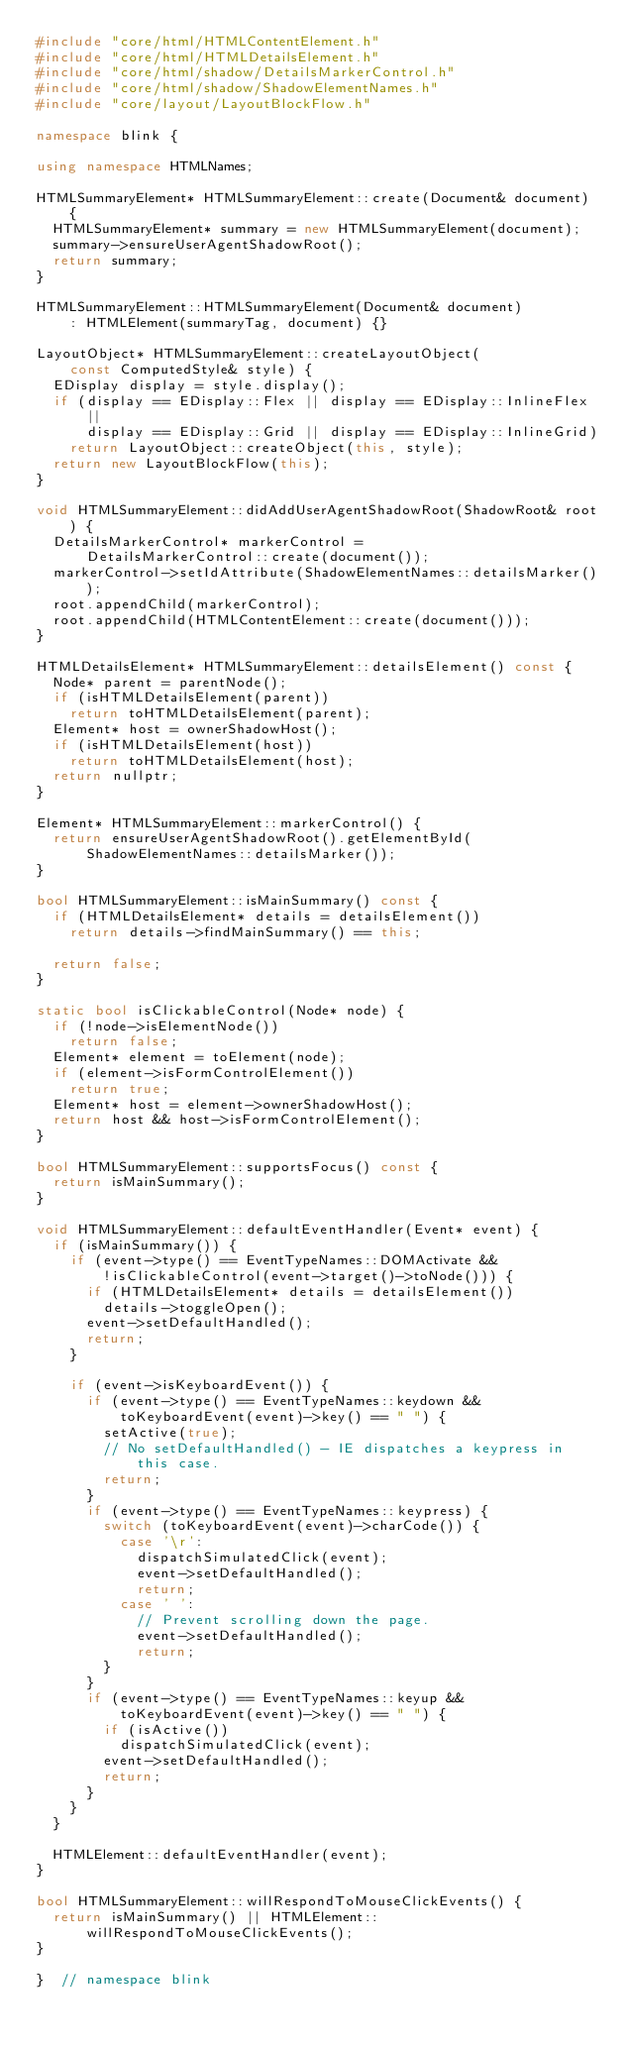<code> <loc_0><loc_0><loc_500><loc_500><_C++_>#include "core/html/HTMLContentElement.h"
#include "core/html/HTMLDetailsElement.h"
#include "core/html/shadow/DetailsMarkerControl.h"
#include "core/html/shadow/ShadowElementNames.h"
#include "core/layout/LayoutBlockFlow.h"

namespace blink {

using namespace HTMLNames;

HTMLSummaryElement* HTMLSummaryElement::create(Document& document) {
  HTMLSummaryElement* summary = new HTMLSummaryElement(document);
  summary->ensureUserAgentShadowRoot();
  return summary;
}

HTMLSummaryElement::HTMLSummaryElement(Document& document)
    : HTMLElement(summaryTag, document) {}

LayoutObject* HTMLSummaryElement::createLayoutObject(
    const ComputedStyle& style) {
  EDisplay display = style.display();
  if (display == EDisplay::Flex || display == EDisplay::InlineFlex ||
      display == EDisplay::Grid || display == EDisplay::InlineGrid)
    return LayoutObject::createObject(this, style);
  return new LayoutBlockFlow(this);
}

void HTMLSummaryElement::didAddUserAgentShadowRoot(ShadowRoot& root) {
  DetailsMarkerControl* markerControl =
      DetailsMarkerControl::create(document());
  markerControl->setIdAttribute(ShadowElementNames::detailsMarker());
  root.appendChild(markerControl);
  root.appendChild(HTMLContentElement::create(document()));
}

HTMLDetailsElement* HTMLSummaryElement::detailsElement() const {
  Node* parent = parentNode();
  if (isHTMLDetailsElement(parent))
    return toHTMLDetailsElement(parent);
  Element* host = ownerShadowHost();
  if (isHTMLDetailsElement(host))
    return toHTMLDetailsElement(host);
  return nullptr;
}

Element* HTMLSummaryElement::markerControl() {
  return ensureUserAgentShadowRoot().getElementById(
      ShadowElementNames::detailsMarker());
}

bool HTMLSummaryElement::isMainSummary() const {
  if (HTMLDetailsElement* details = detailsElement())
    return details->findMainSummary() == this;

  return false;
}

static bool isClickableControl(Node* node) {
  if (!node->isElementNode())
    return false;
  Element* element = toElement(node);
  if (element->isFormControlElement())
    return true;
  Element* host = element->ownerShadowHost();
  return host && host->isFormControlElement();
}

bool HTMLSummaryElement::supportsFocus() const {
  return isMainSummary();
}

void HTMLSummaryElement::defaultEventHandler(Event* event) {
  if (isMainSummary()) {
    if (event->type() == EventTypeNames::DOMActivate &&
        !isClickableControl(event->target()->toNode())) {
      if (HTMLDetailsElement* details = detailsElement())
        details->toggleOpen();
      event->setDefaultHandled();
      return;
    }

    if (event->isKeyboardEvent()) {
      if (event->type() == EventTypeNames::keydown &&
          toKeyboardEvent(event)->key() == " ") {
        setActive(true);
        // No setDefaultHandled() - IE dispatches a keypress in this case.
        return;
      }
      if (event->type() == EventTypeNames::keypress) {
        switch (toKeyboardEvent(event)->charCode()) {
          case '\r':
            dispatchSimulatedClick(event);
            event->setDefaultHandled();
            return;
          case ' ':
            // Prevent scrolling down the page.
            event->setDefaultHandled();
            return;
        }
      }
      if (event->type() == EventTypeNames::keyup &&
          toKeyboardEvent(event)->key() == " ") {
        if (isActive())
          dispatchSimulatedClick(event);
        event->setDefaultHandled();
        return;
      }
    }
  }

  HTMLElement::defaultEventHandler(event);
}

bool HTMLSummaryElement::willRespondToMouseClickEvents() {
  return isMainSummary() || HTMLElement::willRespondToMouseClickEvents();
}

}  // namespace blink
</code> 